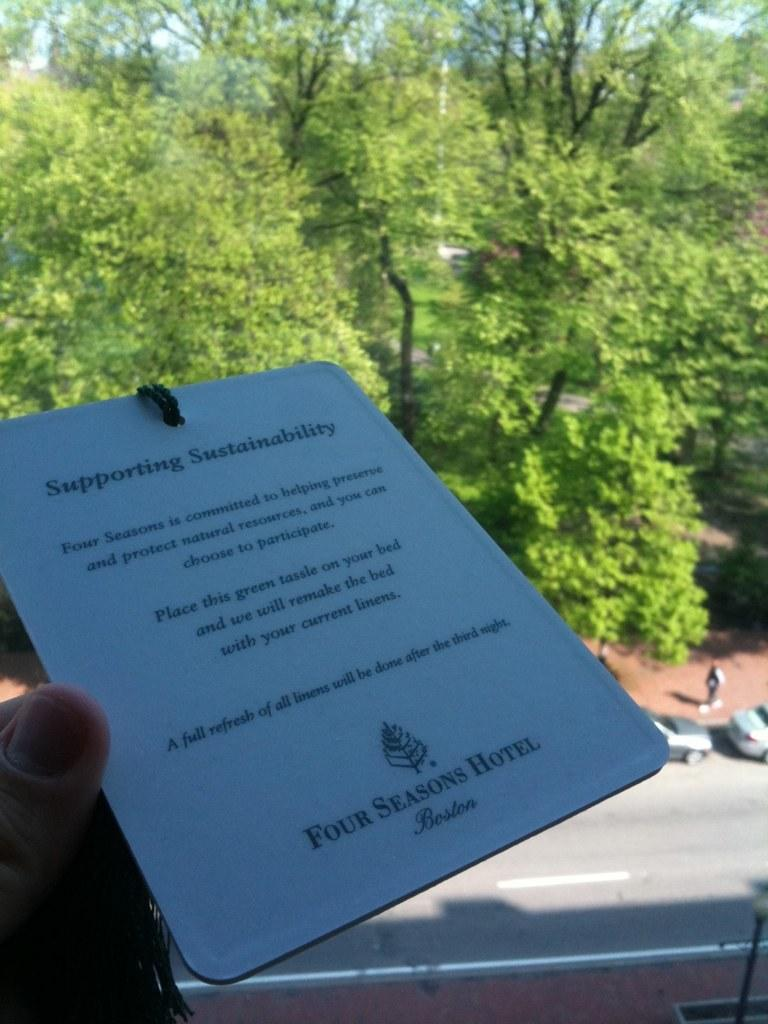What is the main object in the center of the image? There is a paper in the center of the image. Who is holding the paper? The paper is being held in a hand. What can be seen in the background of the image? There are trees, vehicles, and a person in the background. What part of the natural environment is visible in the image? The sky is visible in the background. What type of music is the band playing in the background of the image? There is no band present in the image, so it is not possible to determine what type of music might be playing. 